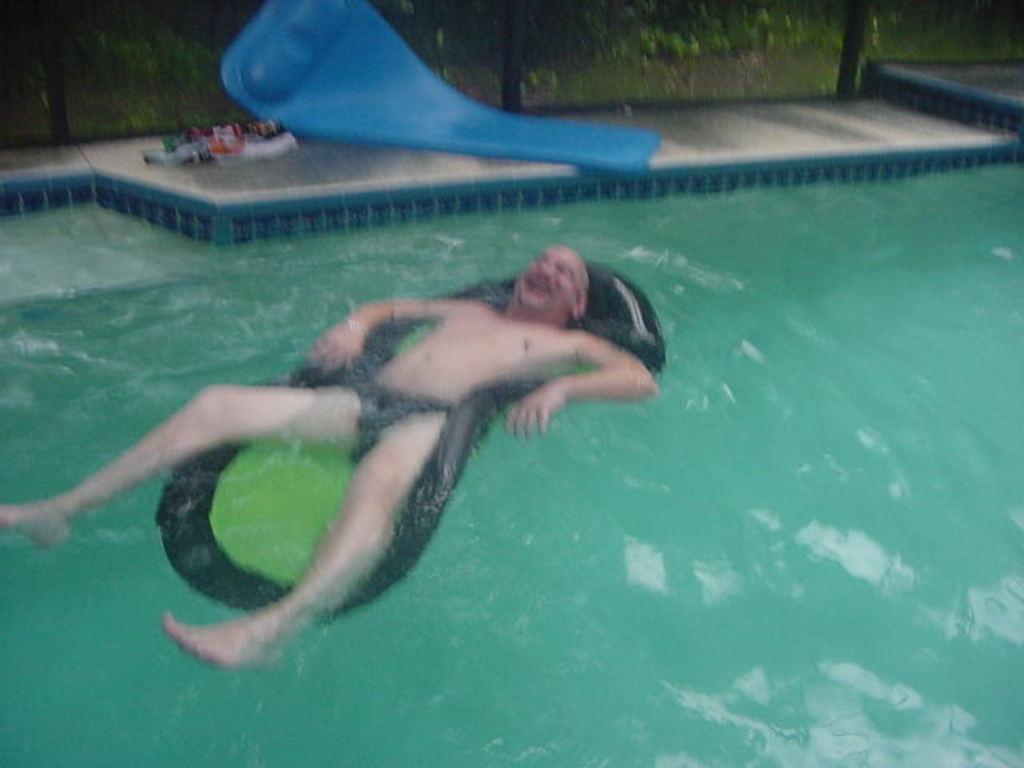What is the person in the image doing? The person is lying on a float water mat in the swimming pool. Can you describe the other object in the image? There is another float water mat on the ground. What type of pump is used to inflate the float water mats in the image? There is no pump visible in the image, and it is not mentioned that the float water mats are inflated. 